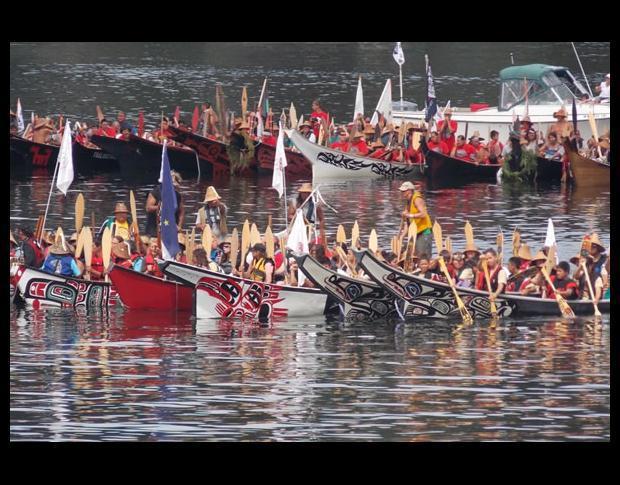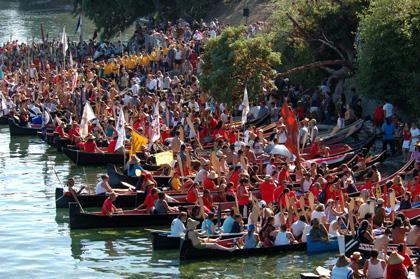The first image is the image on the left, the second image is the image on the right. Evaluate the accuracy of this statement regarding the images: "At least half a dozen boats sit in the water in the image on the right.". Is it true? Answer yes or no. Yes. The first image is the image on the left, the second image is the image on the right. Evaluate the accuracy of this statement regarding the images: "One of the images contains three or less boats.". Is it true? Answer yes or no. No. 